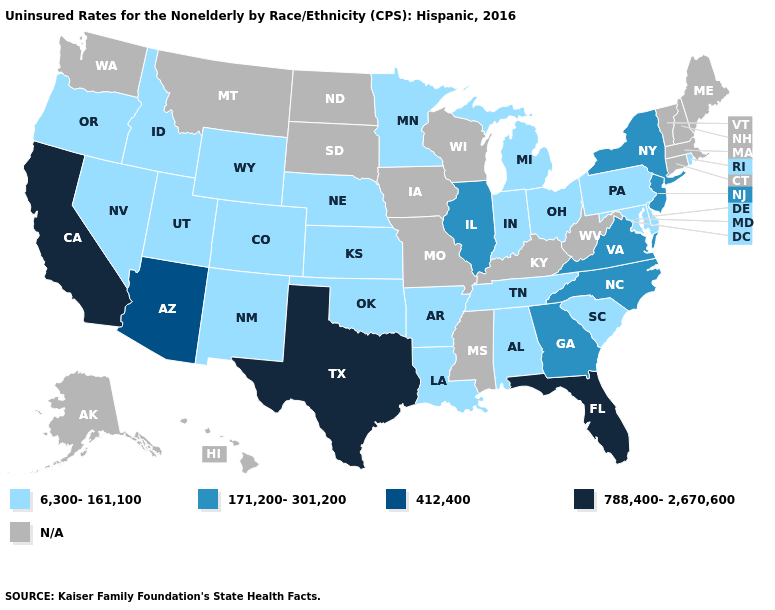What is the value of Colorado?
Write a very short answer. 6,300-161,100. What is the value of Tennessee?
Quick response, please. 6,300-161,100. Name the states that have a value in the range N/A?
Be succinct. Alaska, Connecticut, Hawaii, Iowa, Kentucky, Maine, Massachusetts, Mississippi, Missouri, Montana, New Hampshire, North Dakota, South Dakota, Vermont, Washington, West Virginia, Wisconsin. Is the legend a continuous bar?
Answer briefly. No. Name the states that have a value in the range N/A?
Quick response, please. Alaska, Connecticut, Hawaii, Iowa, Kentucky, Maine, Massachusetts, Mississippi, Missouri, Montana, New Hampshire, North Dakota, South Dakota, Vermont, Washington, West Virginia, Wisconsin. Name the states that have a value in the range 171,200-301,200?
Keep it brief. Georgia, Illinois, New Jersey, New York, North Carolina, Virginia. Among the states that border Kansas , which have the highest value?
Concise answer only. Colorado, Nebraska, Oklahoma. What is the value of Georgia?
Answer briefly. 171,200-301,200. What is the value of Missouri?
Quick response, please. N/A. Which states have the lowest value in the Northeast?
Give a very brief answer. Pennsylvania, Rhode Island. What is the value of Washington?
Short answer required. N/A. 